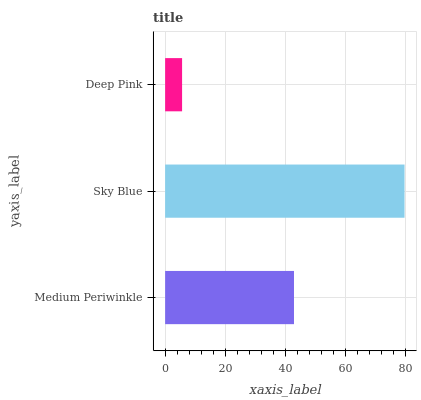Is Deep Pink the minimum?
Answer yes or no. Yes. Is Sky Blue the maximum?
Answer yes or no. Yes. Is Sky Blue the minimum?
Answer yes or no. No. Is Deep Pink the maximum?
Answer yes or no. No. Is Sky Blue greater than Deep Pink?
Answer yes or no. Yes. Is Deep Pink less than Sky Blue?
Answer yes or no. Yes. Is Deep Pink greater than Sky Blue?
Answer yes or no. No. Is Sky Blue less than Deep Pink?
Answer yes or no. No. Is Medium Periwinkle the high median?
Answer yes or no. Yes. Is Medium Periwinkle the low median?
Answer yes or no. Yes. Is Sky Blue the high median?
Answer yes or no. No. Is Sky Blue the low median?
Answer yes or no. No. 